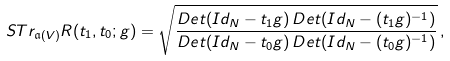Convert formula to latex. <formula><loc_0><loc_0><loc_500><loc_500>S T r _ { \mathfrak { a } ( V ) } R ( t _ { 1 } , t _ { 0 } ; g ) = \sqrt { \frac { D e t ( I d _ { N } - t _ { 1 } g ) \, D e t ( I d _ { N } - ( t _ { 1 } g ) ^ { - 1 } ) } { D e t ( I d _ { N } - t _ { 0 } g ) \, D e t ( I d _ { N } - ( t _ { 0 } g ) ^ { - 1 } ) } } \, ,</formula> 